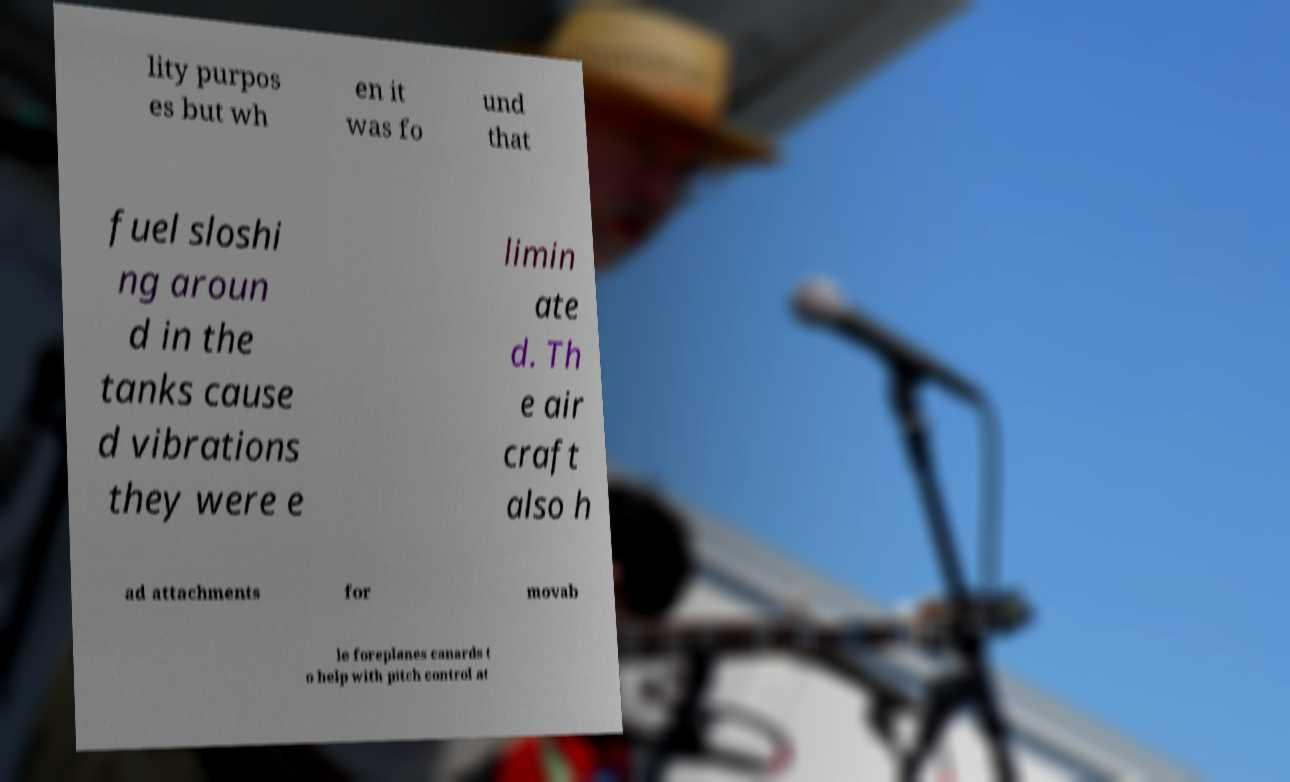Please read and relay the text visible in this image. What does it say? lity purpos es but wh en it was fo und that fuel sloshi ng aroun d in the tanks cause d vibrations they were e limin ate d. Th e air craft also h ad attachments for movab le foreplanes canards t o help with pitch control at 